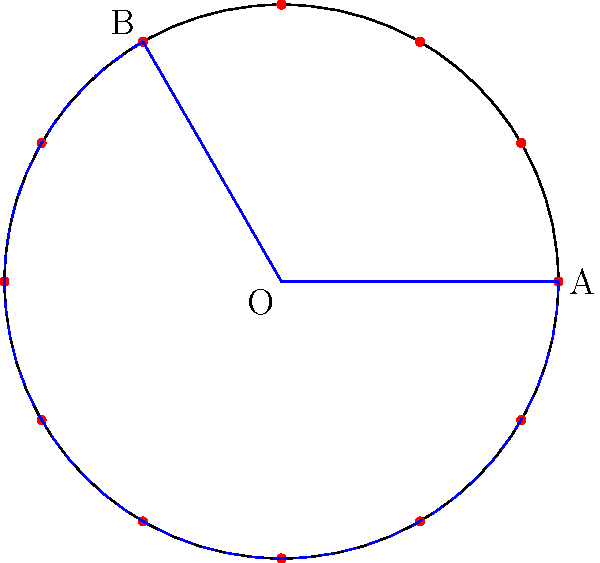In a circular hula dance formation, 12 dancers are evenly spaced around the circle. If the arc between two dancers spans 4 positions (including the start and end positions), what is the central angle (in degrees) formed by the sector containing these 4 dancers? Let's approach this step-by-step:

1) First, we need to understand what the question is asking. We're looking for the central angle of a sector that spans 4 dancer positions out of 12 total positions.

2) In a circle, the total angle is 360°. With 12 dancers evenly spaced, each dancer occupies:

   $$\frac{360°}{12} = 30°$$ of the circle.

3) The sector we're interested in spans 4 positions. However, we need to be careful here. The arc between two adjacent dancers represents one interval, which is 30°. 

4) To find the total angle, we need to multiply the angle per interval by the number of intervals:

   Number of intervals = 4 - 1 = 3 (because 4 positions include 3 intervals)

5) Therefore, the central angle is:

   $$3 \times 30° = 90°$$

This means the sector containing these 4 dancers spans a quarter of the circle, or 90°.
Answer: 90° 